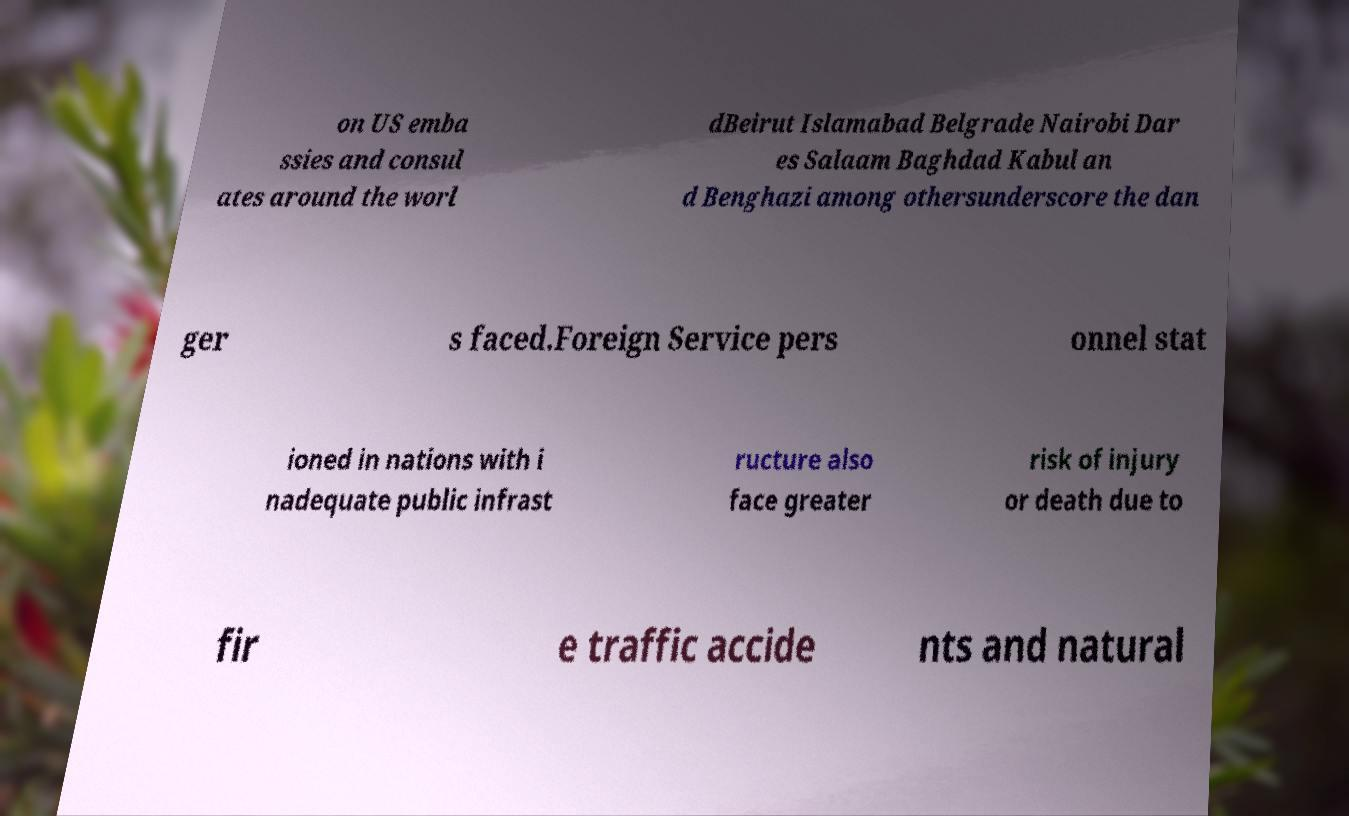Can you accurately transcribe the text from the provided image for me? on US emba ssies and consul ates around the worl dBeirut Islamabad Belgrade Nairobi Dar es Salaam Baghdad Kabul an d Benghazi among othersunderscore the dan ger s faced.Foreign Service pers onnel stat ioned in nations with i nadequate public infrast ructure also face greater risk of injury or death due to fir e traffic accide nts and natural 